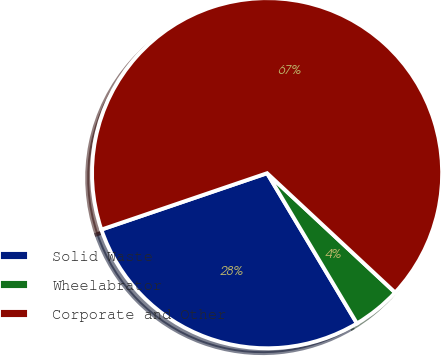<chart> <loc_0><loc_0><loc_500><loc_500><pie_chart><fcel>Solid Waste<fcel>Wheelabrator<fcel>Corporate and Other<nl><fcel>28.36%<fcel>4.48%<fcel>67.16%<nl></chart> 